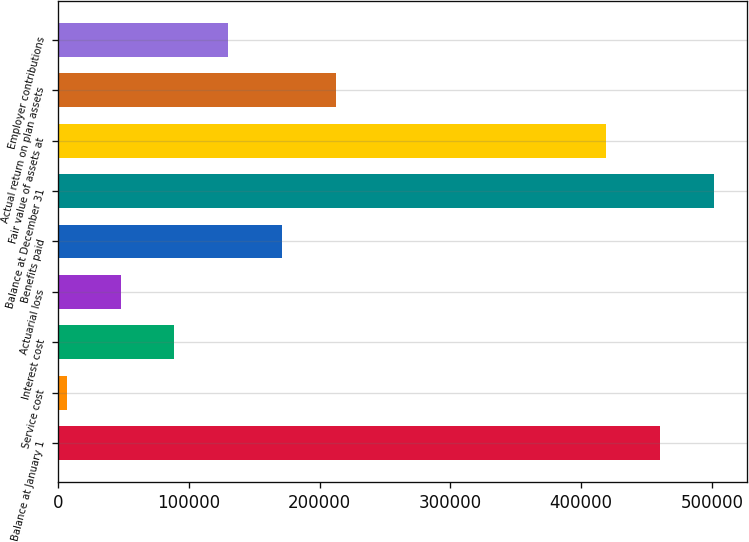Convert chart to OTSL. <chart><loc_0><loc_0><loc_500><loc_500><bar_chart><fcel>Balance at January 1<fcel>Service cost<fcel>Interest cost<fcel>Actuarial loss<fcel>Benefits paid<fcel>Balance at December 31<fcel>Fair value of assets at<fcel>Actual return on plan assets<fcel>Employer contributions<nl><fcel>460496<fcel>6250<fcel>88840.2<fcel>47545.1<fcel>171430<fcel>501791<fcel>419201<fcel>212726<fcel>130135<nl></chart> 